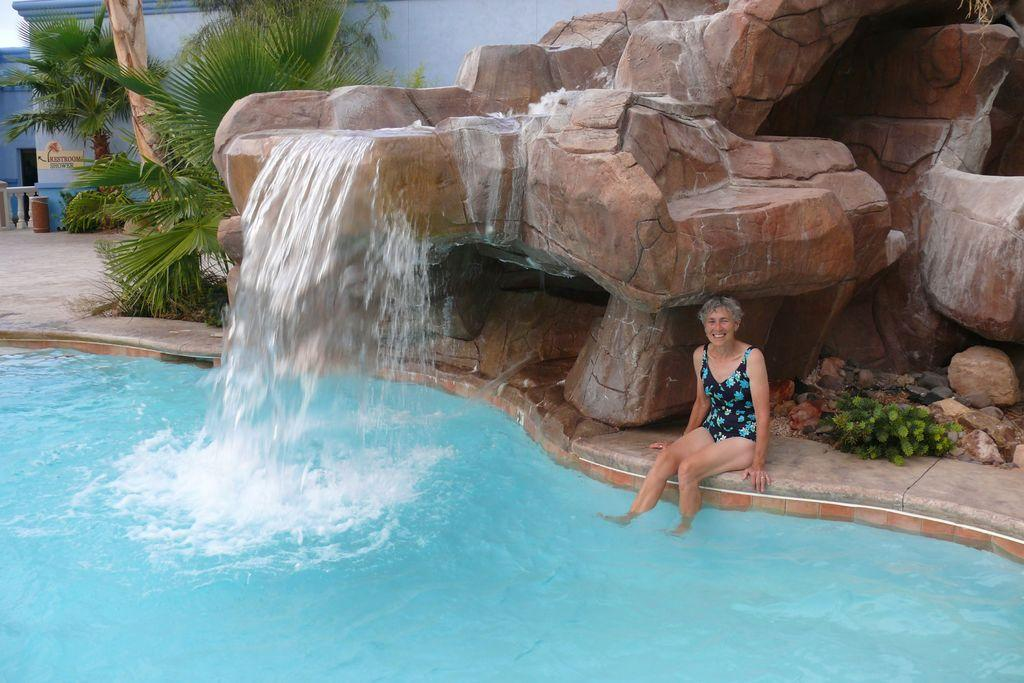What is the person in the image doing? The person is sitting near the pool. What is located behind the person? Rocks are located behind the person. What is happening with the water near the rocks? Water is falling from the rocks into the pool. What can be seen in the background of the image? There is a building and trees in the background. What type of celery can be seen growing near the pool in the image? There is no celery present in the image; it features a person sitting near a pool with rocks and water falling into it. 